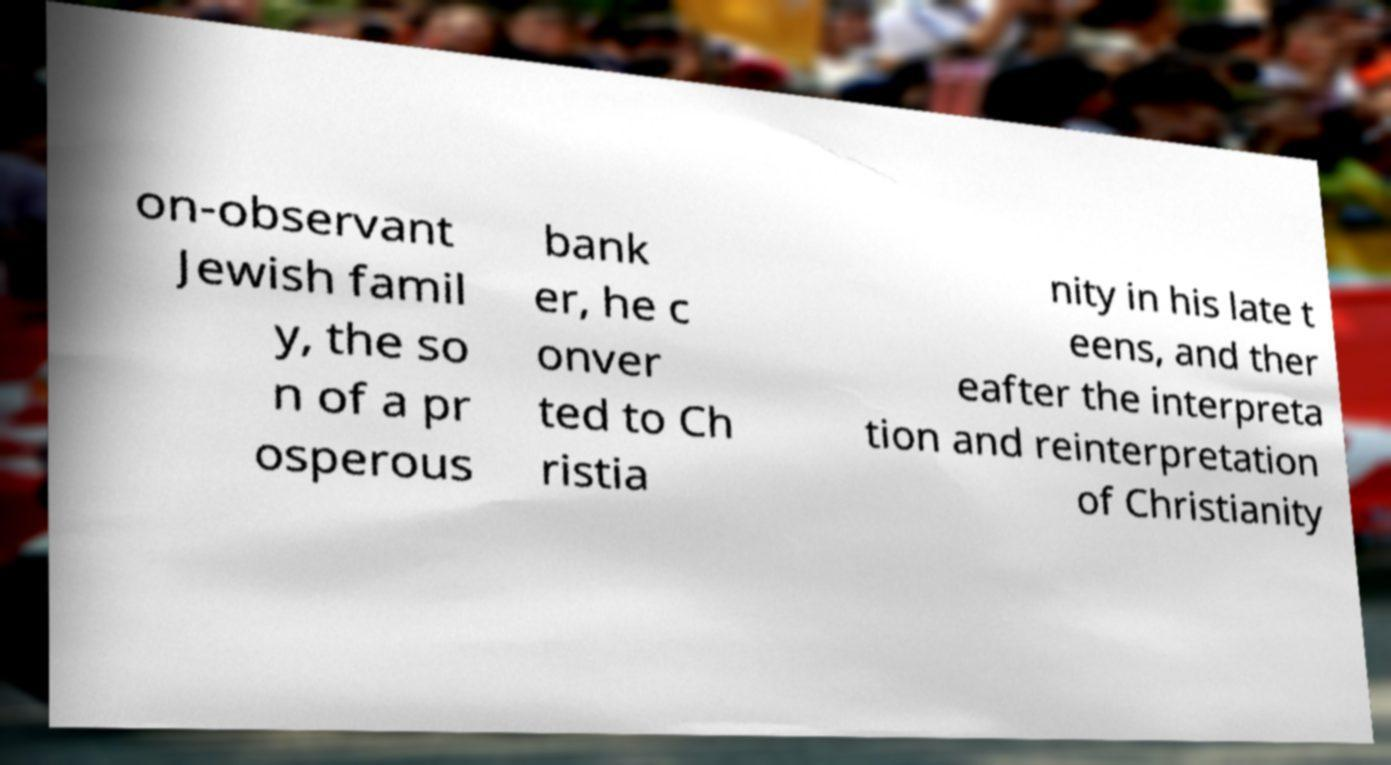Can you accurately transcribe the text from the provided image for me? on-observant Jewish famil y, the so n of a pr osperous bank er, he c onver ted to Ch ristia nity in his late t eens, and ther eafter the interpreta tion and reinterpretation of Christianity 